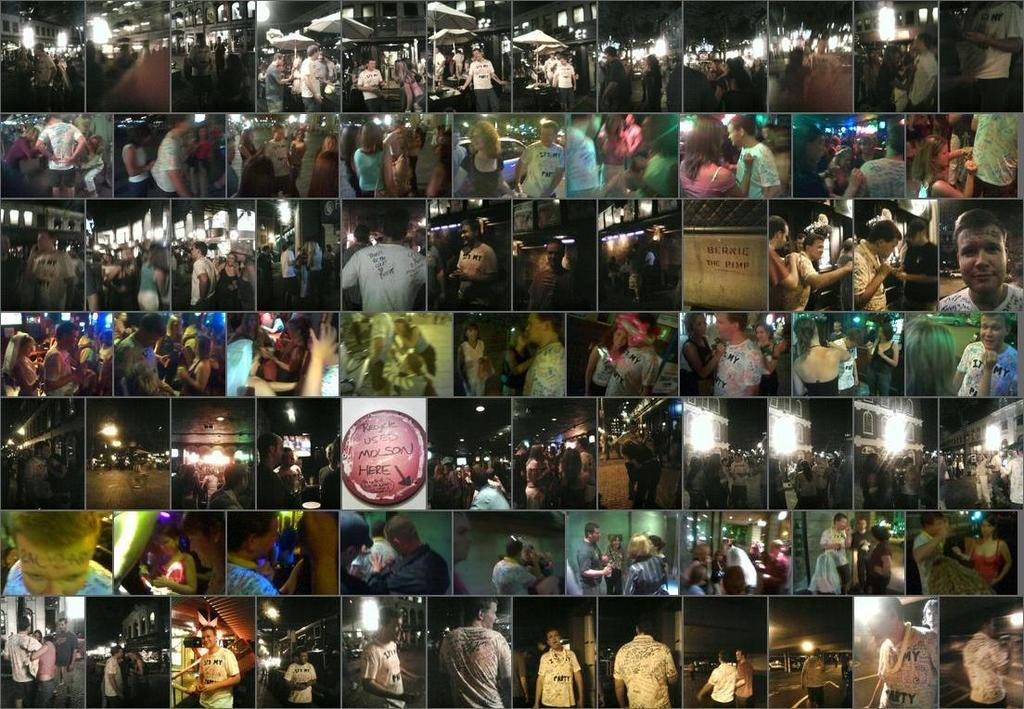What songs can be heard being sung by the wind in the image? There is no wind or singing in the image, so it is not possible to determine what songs might be heard. 